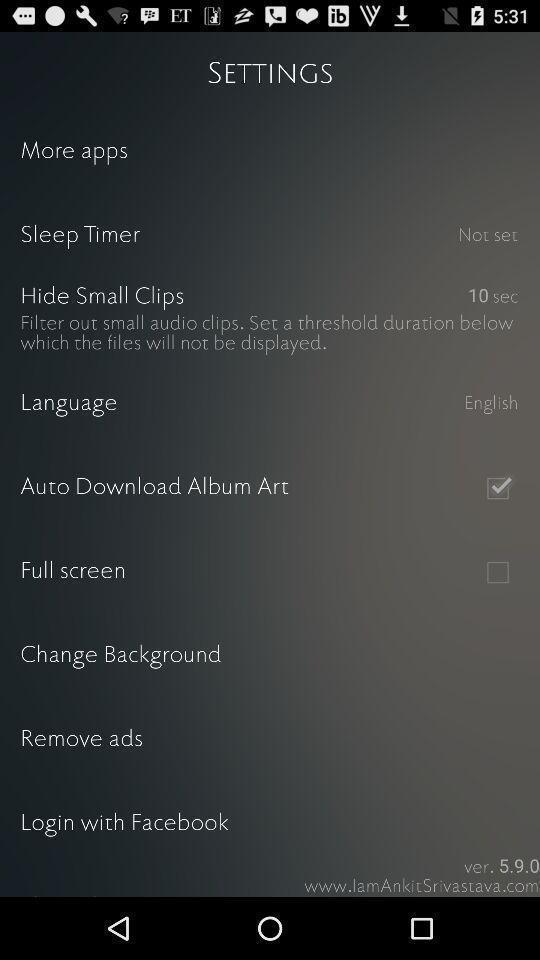Summarize the main components in this picture. Settings page displayed. 